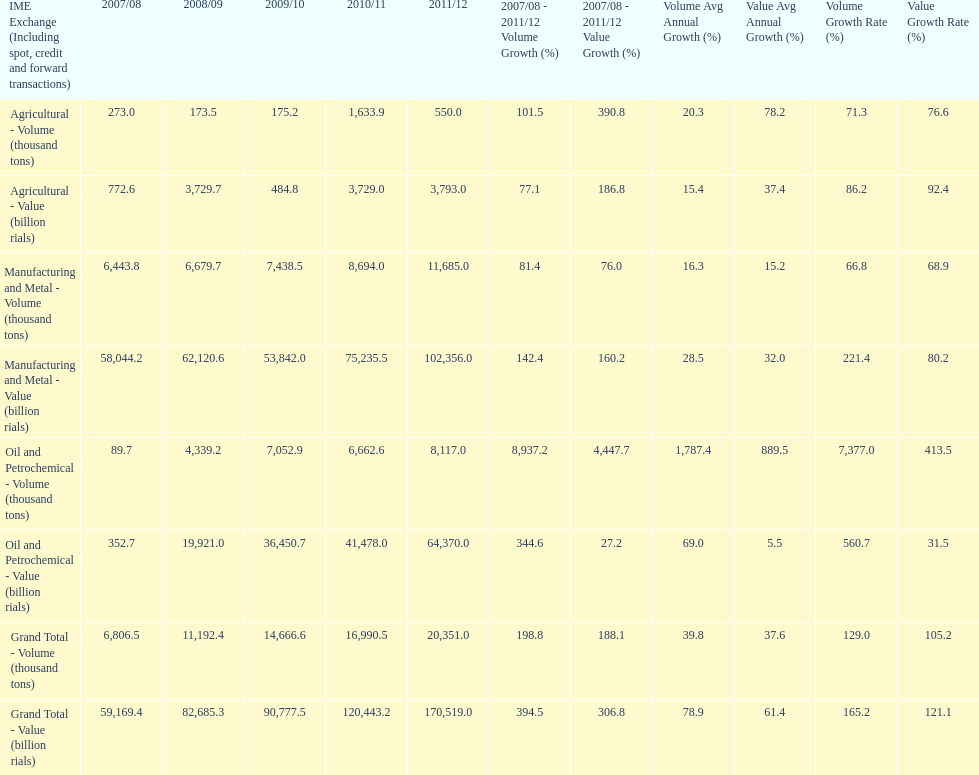Did 2010/11 or 2011/12 make more in grand total value? 2011/12. 